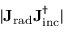<formula> <loc_0><loc_0><loc_500><loc_500>| J _ { r a d } J _ { i n c } ^ { \dagger } |</formula> 